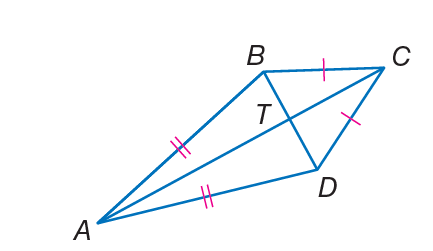Answer the mathemtical geometry problem and directly provide the correct option letter.
Question: If m \angle B A D = 38 and m \angle B C D = 50, find m \angle A D C.
Choices: A: 12 B: 34 C: 56 D: 146 D 